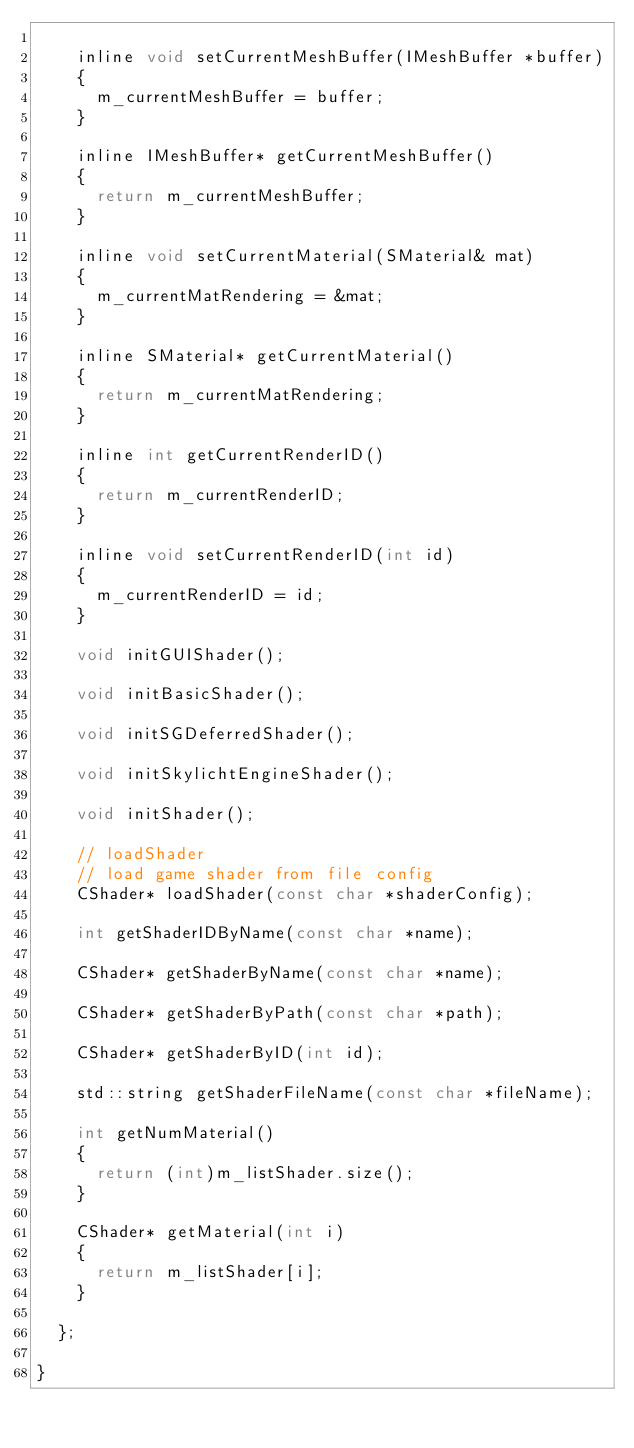<code> <loc_0><loc_0><loc_500><loc_500><_C_>
		inline void setCurrentMeshBuffer(IMeshBuffer *buffer)
		{
			m_currentMeshBuffer = buffer;
		}

		inline IMeshBuffer* getCurrentMeshBuffer()
		{
			return m_currentMeshBuffer;
		}

		inline void setCurrentMaterial(SMaterial& mat)
		{
			m_currentMatRendering = &mat;
		}

		inline SMaterial* getCurrentMaterial()
		{
			return m_currentMatRendering;
		}

		inline int getCurrentRenderID()
		{
			return m_currentRenderID;
		}

		inline void setCurrentRenderID(int id)
		{
			m_currentRenderID = id;
		}

		void initGUIShader();

		void initBasicShader();

		void initSGDeferredShader();

		void initSkylichtEngineShader();

		void initShader();

		// loadShader
		// load game shader from file config
		CShader* loadShader(const char *shaderConfig);

		int getShaderIDByName(const char *name);

		CShader* getShaderByName(const char *name);

		CShader* getShaderByPath(const char *path);

		CShader* getShaderByID(int id);

		std::string getShaderFileName(const char *fileName);

		int getNumMaterial()
		{
			return (int)m_listShader.size();
		}

		CShader* getMaterial(int i)
		{
			return m_listShader[i];
		}

	};

}</code> 